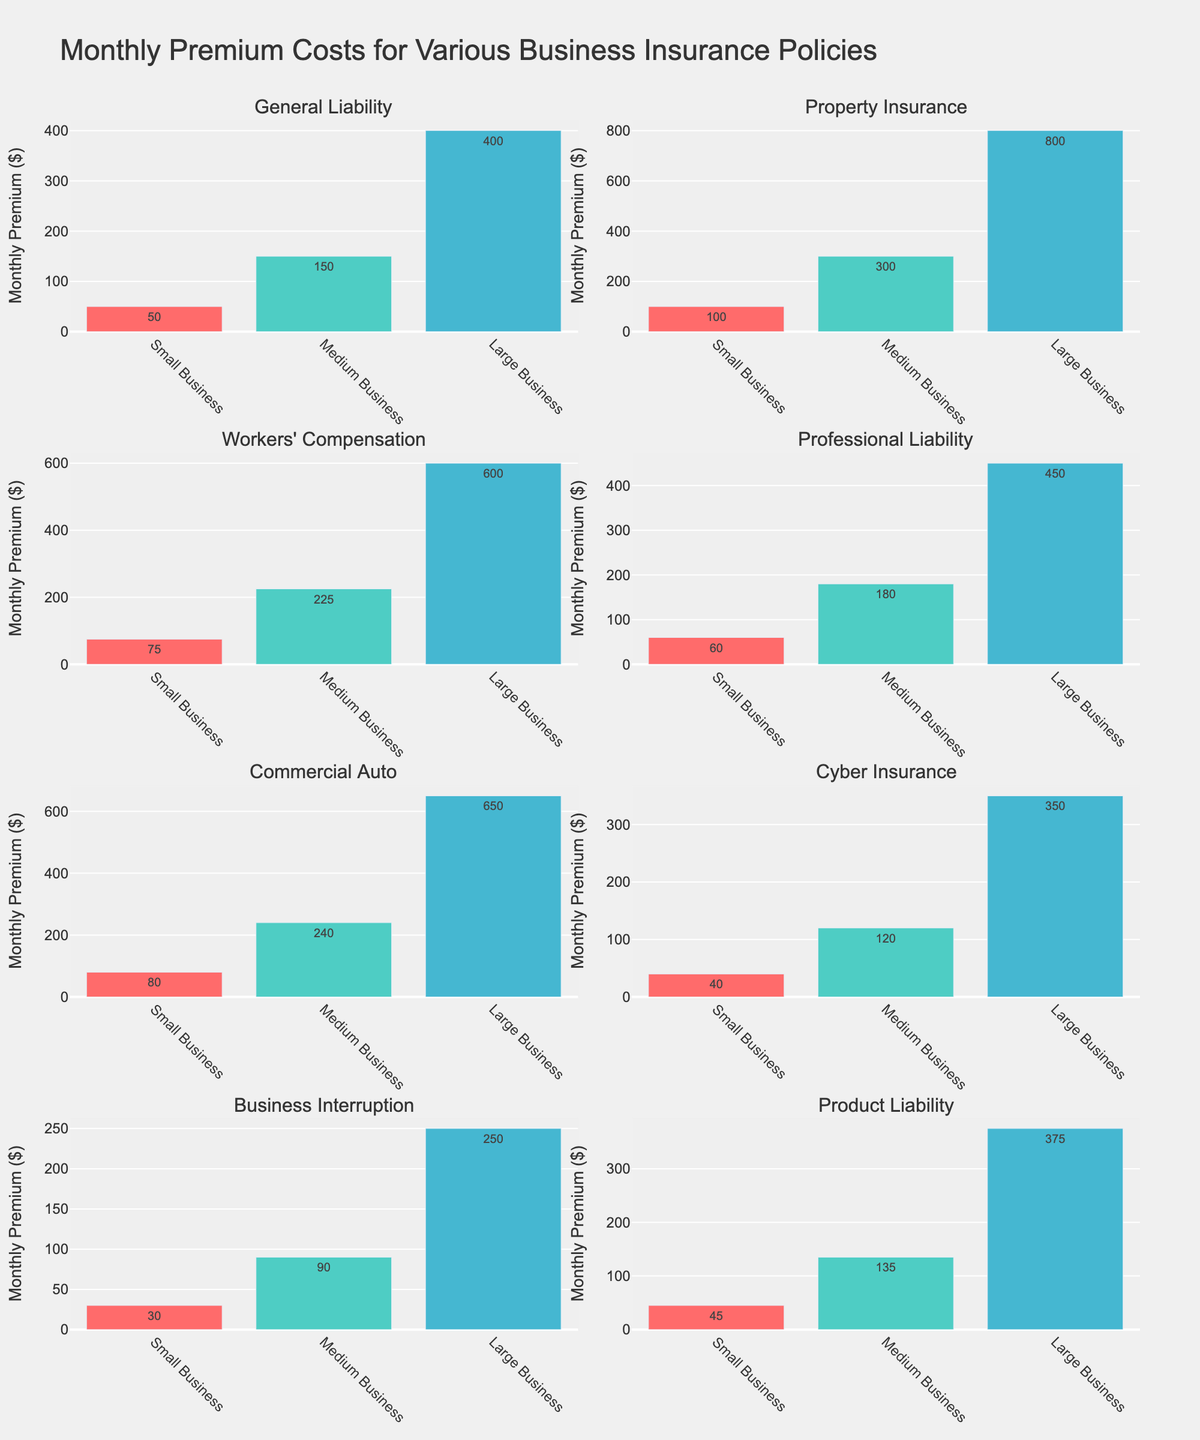What is the title of the figure? The title of the figure is displayed at the center of the plot, above the subplots. It reads "Police Response Times for Various Emergencies".
Answer: Police Response Times for Various Emergencies What is the response time for Fire emergencies in Los Angeles? Locate the subplot with the title "Fire". In this subplot, find the bar corresponding to Los Angeles. The height of the bar shows the response time, which is 3 minutes according to the label on the bar.
Answer: 3 minutes Among the emergency types shown, which one has the shortest response time in New York? Locate the bars corresponding to New York across all subplots. Compare their heights and the labels. The shortest response time in New York is for Fire emergencies, which is 4 minutes.
Answer: Fire What is the average response time for Burglary emergencies across all cities? Locate the subplot for Burglary. Note the response times for all cities: 12 (New York), 15 (Chicago), 10 (Los Angeles), and 18 (Houston). Calculate the average: (12 + 15 + 10 + 18) / 4 = 13.75.
Answer: 13.75 minutes Which emergency type has the highest response time in Houston? Check the Houston bars in each subplot and note their response times: Burglary (18), Domestic Violence (13), Assault (10), Medical Emergency (8), Fire (7). The highest response time is for Burglary, with 18 minutes.
Answer: Burglary Compare the response times for Domestic Violence emergencies in Chicago and Los Angeles. Which city has the faster response? Locate the subplot for Domestic Violence. Check the response times for Chicago (11 minutes) and Los Angeles (7 minutes). Los Angeles has the faster response time.
Answer: Los Angeles How many emergency types are displayed in the figure? Examine the number of subplot titles. There are five subplot titles, one for each emergency type: Burglary, Domestic Violence, Assault, Medical Emergency, and Fire.
Answer: 5 What is the total response time for Medical Emergency across all cities? Locate the subplot for Medical Emergency and note the response times: 5 (New York), 7 (Chicago), 4 (Los Angeles), and 8 (Houston). Calculate the total: 5 + 7 + 4 + 8 = 24 minutes.
Answer: 24 minutes Is the response time for Assault emergencies longer in Chicago or Houston? Find the subplot for Assault and compare the heights and labels of the bars for Chicago (9 minutes) and Houston (10 minutes). The response is longer in Houston.
Answer: Houston 